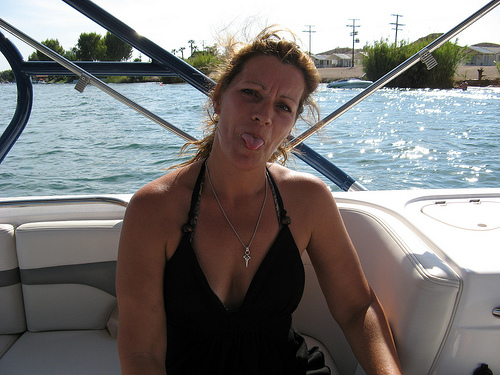<image>
Is there a woman on the boat? Yes. Looking at the image, I can see the woman is positioned on top of the boat, with the boat providing support. 